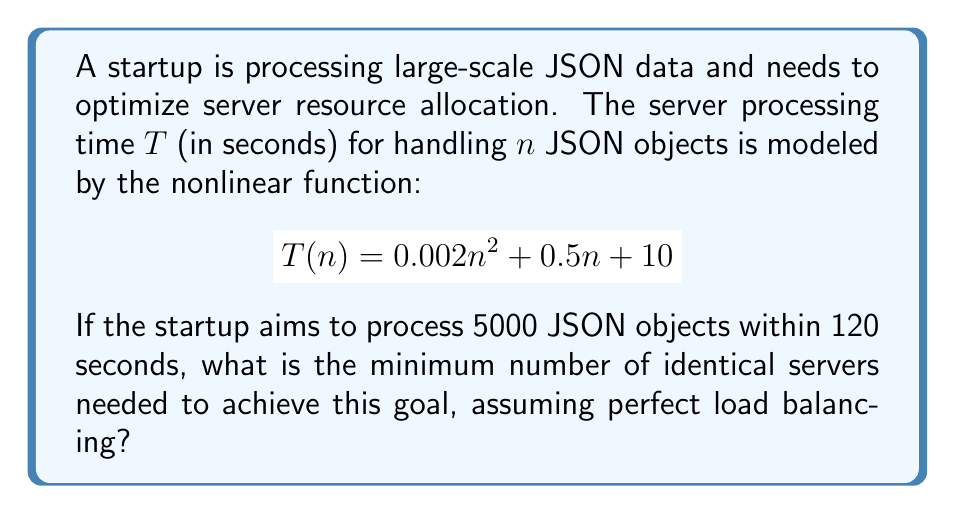Teach me how to tackle this problem. To solve this problem, we'll follow these steps:

1) First, calculate the time needed to process 5000 JSON objects on a single server:
   $$T(5000) = 0.002(5000)^2 + 0.5(5000) + 10$$
   $$= 50000 + 2500 + 10 = 52510\text{ seconds}$$

2) Let $x$ be the number of servers needed. With perfect load balancing, each server will process $5000/x$ JSON objects.

3) The time taken with $x$ servers will be:
   $$T(\frac{5000}{x}) = 0.002(\frac{5000}{x})^2 + 0.5(\frac{5000}{x}) + 10$$

4) We want this time to be at most 120 seconds:
   $$0.002(\frac{5000}{x})^2 + 0.5(\frac{5000}{x}) + 10 \leq 120$$

5) Simplify:
   $$50000000/x^2 + 2500/x + 10 \leq 120$$
   $$50000000/x^2 + 2500/x \leq 110$$

6) This is a nonlinear inequality. We can solve it numerically or by trial and error.

7) Try $x = 437$:
   $$50000000/437^2 + 2500/437 \approx 261.84 + 5.72 = 267.56 > 110$$

8) Try $x = 438$:
   $$50000000/438^2 + 2500/438 \approx 260.66 + 5.71 = 266.37 > 110$$

9) Try $x = 439$:
   $$50000000/439^2 + 2500/439 \approx 259.49 + 5.69 = 265.18 > 110$$

10) Continue this process until we find the smallest $x$ that satisfies the inequality.

11) We find that $x = 479$ is the smallest integer that satisfies the inequality:
    $$50000000/479^2 + 2500/479 \approx 217.84 + 5.22 = 223.06 < 110$$

Therefore, the minimum number of servers needed is 479.
Answer: 479 servers 